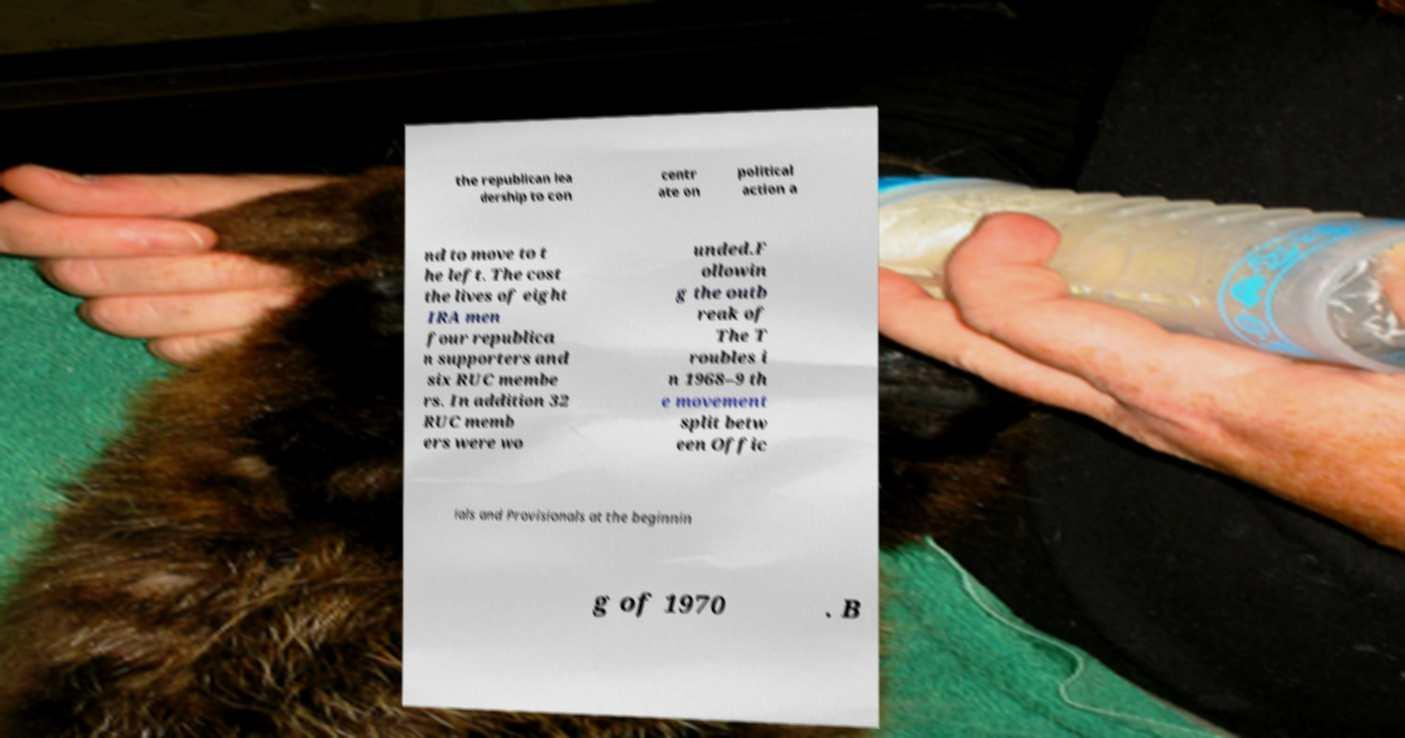Can you read and provide the text displayed in the image?This photo seems to have some interesting text. Can you extract and type it out for me? the republican lea dership to con centr ate on political action a nd to move to t he left. The cost the lives of eight IRA men four republica n supporters and six RUC membe rs. In addition 32 RUC memb ers were wo unded.F ollowin g the outb reak of The T roubles i n 1968–9 th e movement split betw een Offic ials and Provisionals at the beginnin g of 1970 . B 